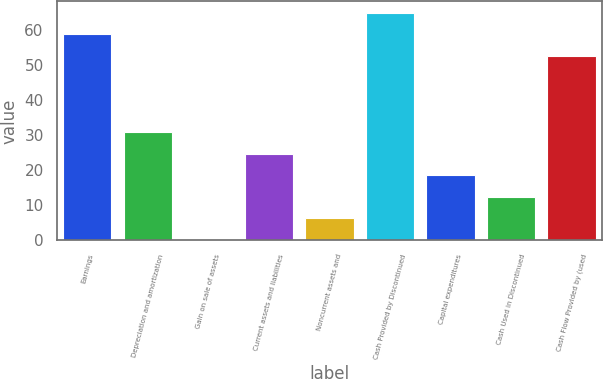Convert chart to OTSL. <chart><loc_0><loc_0><loc_500><loc_500><bar_chart><fcel>Earnings<fcel>Depreciation and amortization<fcel>Gain on sale of assets<fcel>Current assets and liabilities<fcel>Noncurrent assets and<fcel>Cash Provided by Discontinued<fcel>Capital expenditures<fcel>Cash Used in Discontinued<fcel>Cash Flow Provided by (used<nl><fcel>58.83<fcel>30.85<fcel>0.2<fcel>24.72<fcel>6.33<fcel>64.96<fcel>18.59<fcel>12.46<fcel>52.7<nl></chart> 